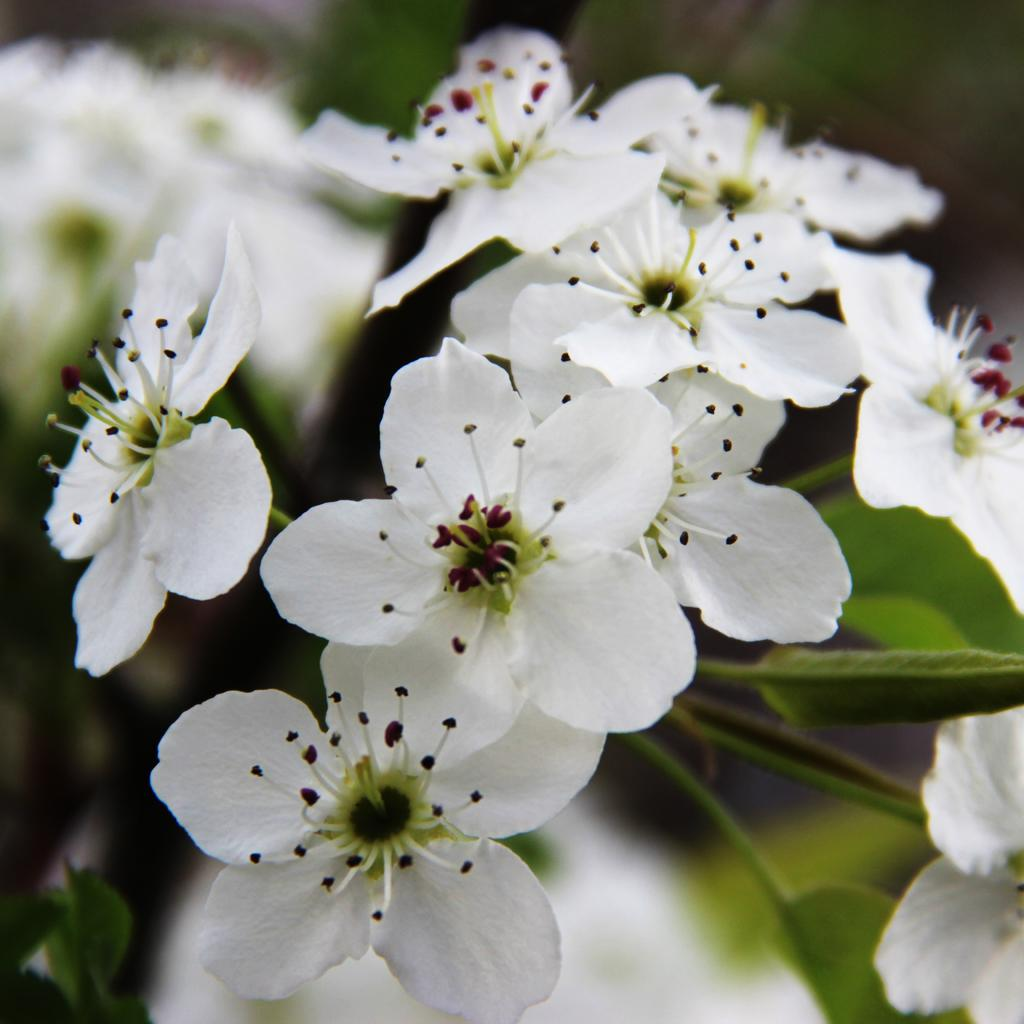What is the main subject of the picture? The main subject of the picture is a plant. What color are the flowers on the plant? The flowers on the plant are white. Can you describe the background of the image? The background of the image is blurred. How many tin objects can be seen hanging from the branches of the plant in the image? There are no tin objects present in the image; it features a plant with white flowers and a blurred background. 